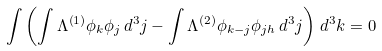<formula> <loc_0><loc_0><loc_500><loc_500>\int \left ( \int \Lambda ^ { \left ( 1 \right ) } \phi _ { k } \phi _ { j } \, d ^ { 3 } { j } - \int \Lambda ^ { \left ( 2 \right ) } \phi _ { k - j } \phi _ { j h } \, d ^ { 3 } { j } \right ) \, d ^ { 3 } { k } = 0</formula> 